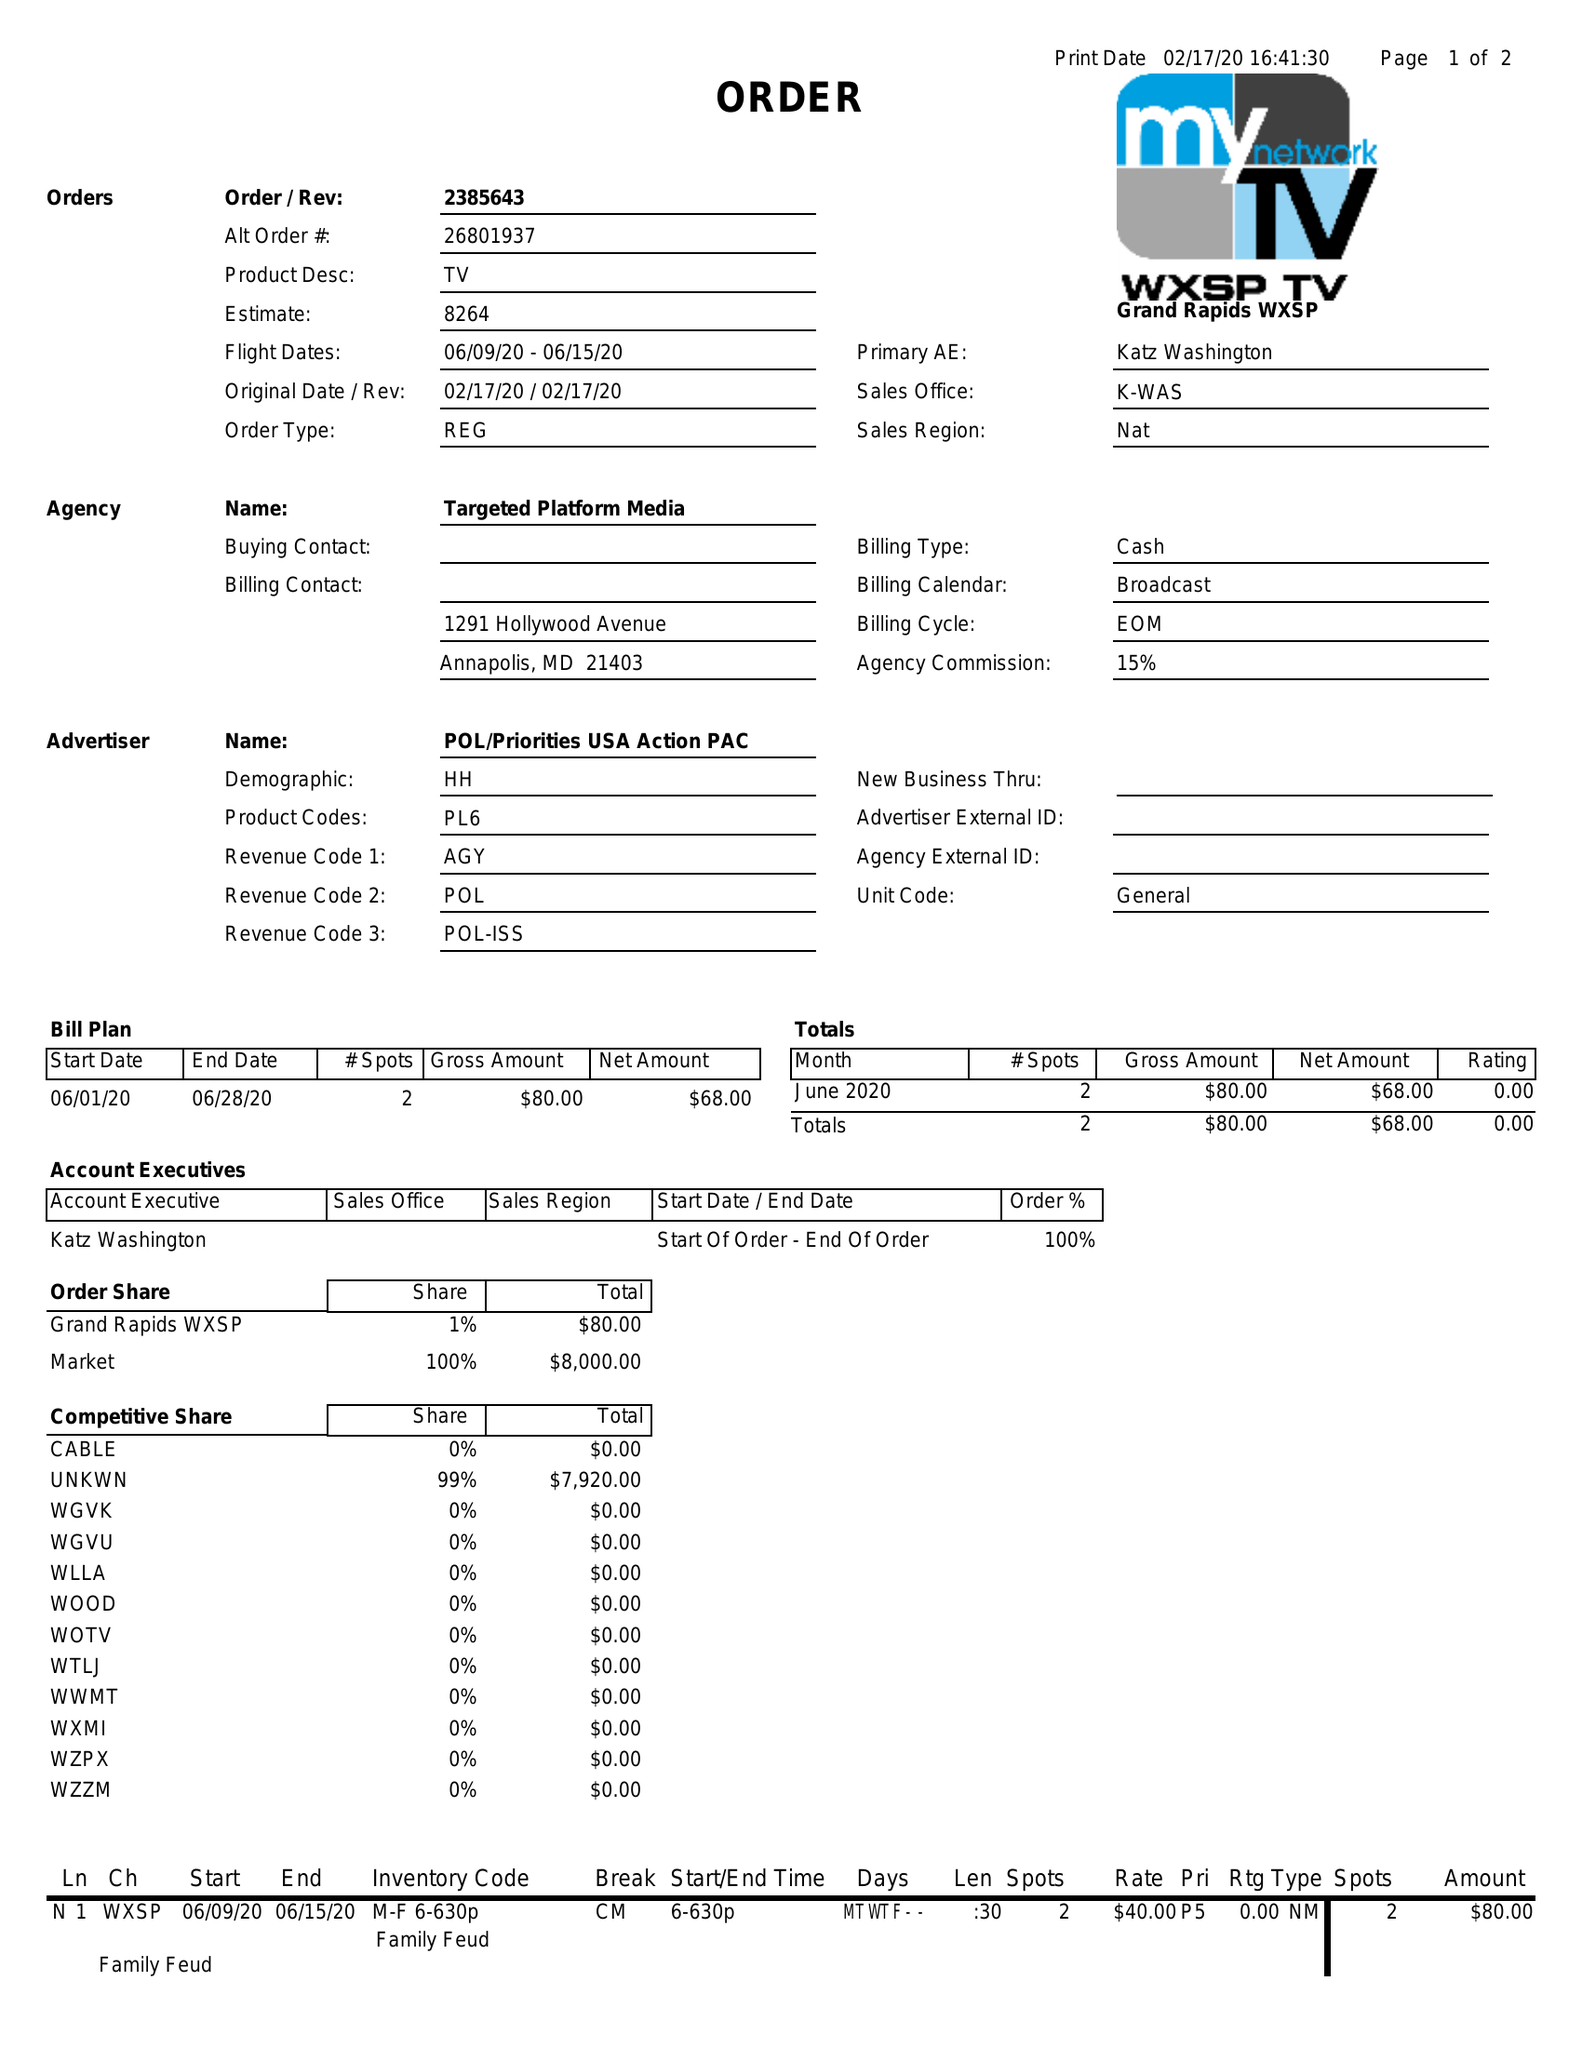What is the value for the contract_num?
Answer the question using a single word or phrase. 2385643 